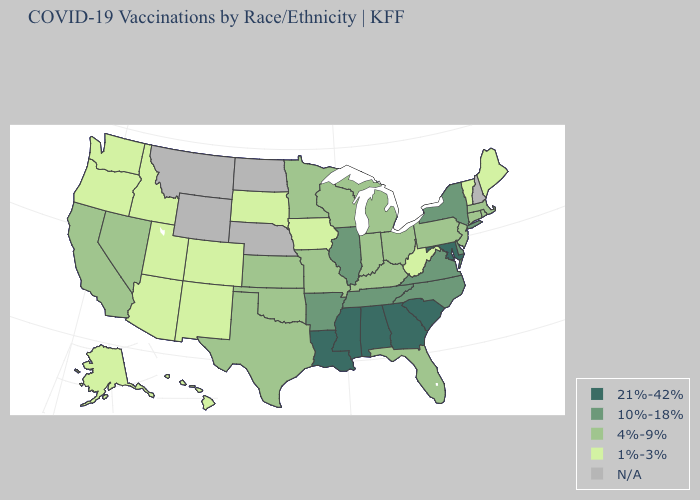Does Maryland have the highest value in the USA?
Answer briefly. Yes. Among the states that border Oklahoma , which have the highest value?
Concise answer only. Arkansas. Which states have the highest value in the USA?
Keep it brief. Alabama, Georgia, Louisiana, Maryland, Mississippi, South Carolina. What is the lowest value in states that border Utah?
Give a very brief answer. 1%-3%. What is the value of Missouri?
Quick response, please. 4%-9%. Name the states that have a value in the range 1%-3%?
Keep it brief. Alaska, Arizona, Colorado, Hawaii, Idaho, Iowa, Maine, New Mexico, Oregon, South Dakota, Utah, Vermont, Washington, West Virginia. Name the states that have a value in the range 1%-3%?
Concise answer only. Alaska, Arizona, Colorado, Hawaii, Idaho, Iowa, Maine, New Mexico, Oregon, South Dakota, Utah, Vermont, Washington, West Virginia. What is the value of Minnesota?
Answer briefly. 4%-9%. Name the states that have a value in the range 21%-42%?
Be succinct. Alabama, Georgia, Louisiana, Maryland, Mississippi, South Carolina. What is the lowest value in states that border South Carolina?
Concise answer only. 10%-18%. Name the states that have a value in the range 21%-42%?
Be succinct. Alabama, Georgia, Louisiana, Maryland, Mississippi, South Carolina. Name the states that have a value in the range 10%-18%?
Answer briefly. Arkansas, Delaware, Illinois, New York, North Carolina, Tennessee, Virginia. What is the highest value in the West ?
Short answer required. 4%-9%. What is the lowest value in the MidWest?
Give a very brief answer. 1%-3%. Name the states that have a value in the range 10%-18%?
Keep it brief. Arkansas, Delaware, Illinois, New York, North Carolina, Tennessee, Virginia. 